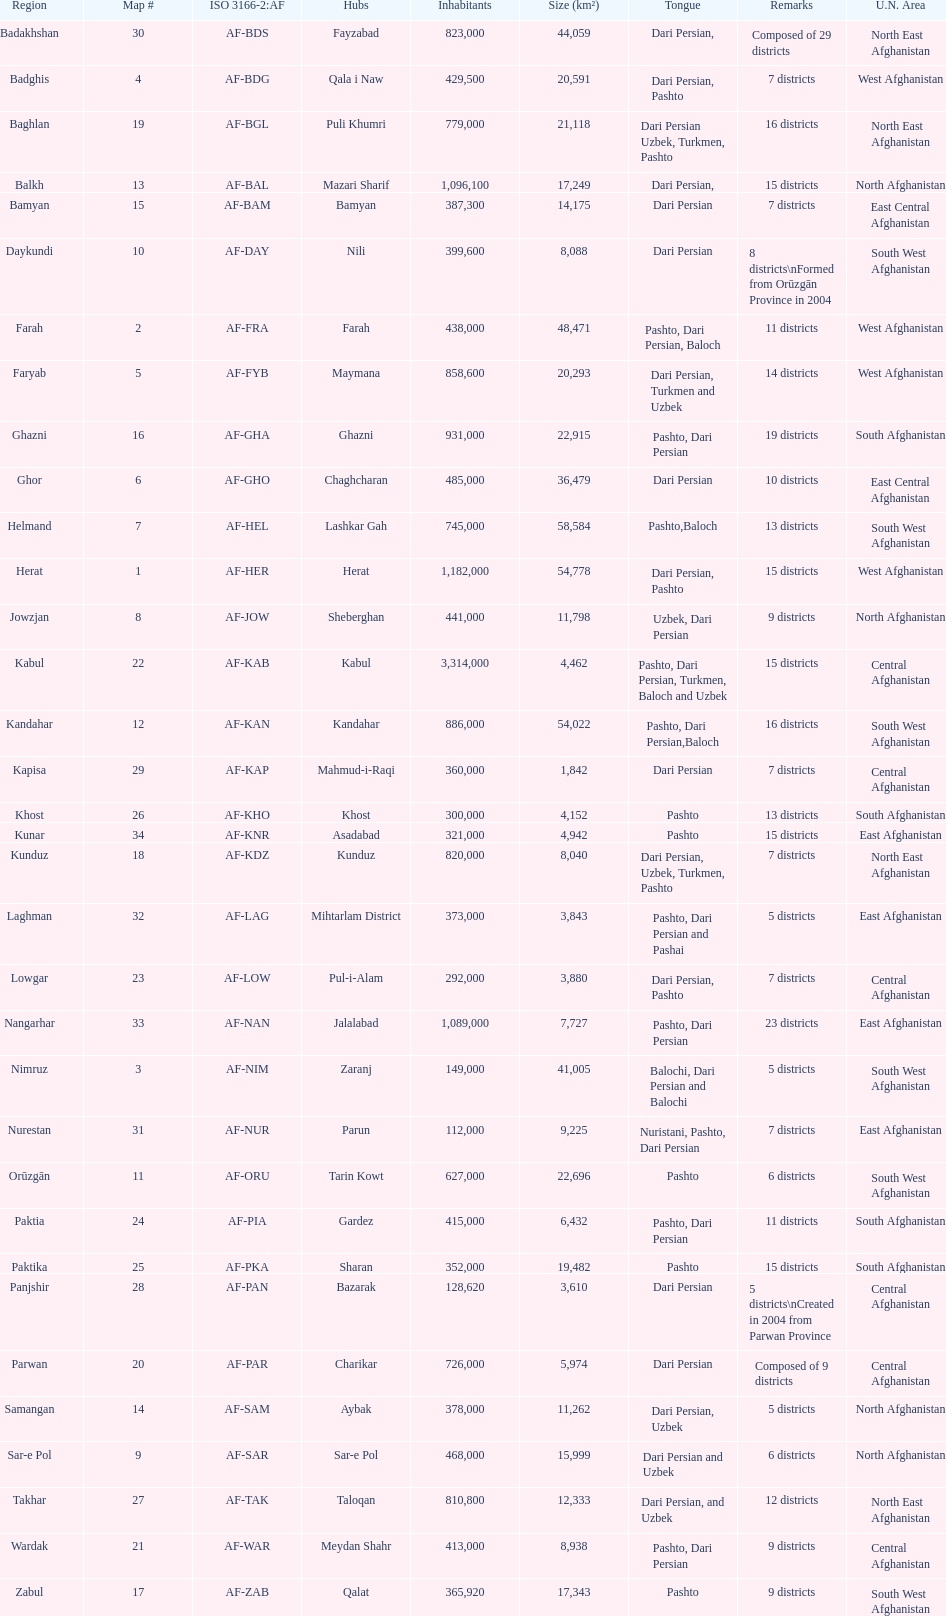Herat has a population of 1,182,000, can you list their languages Dari Persian, Pashto. 